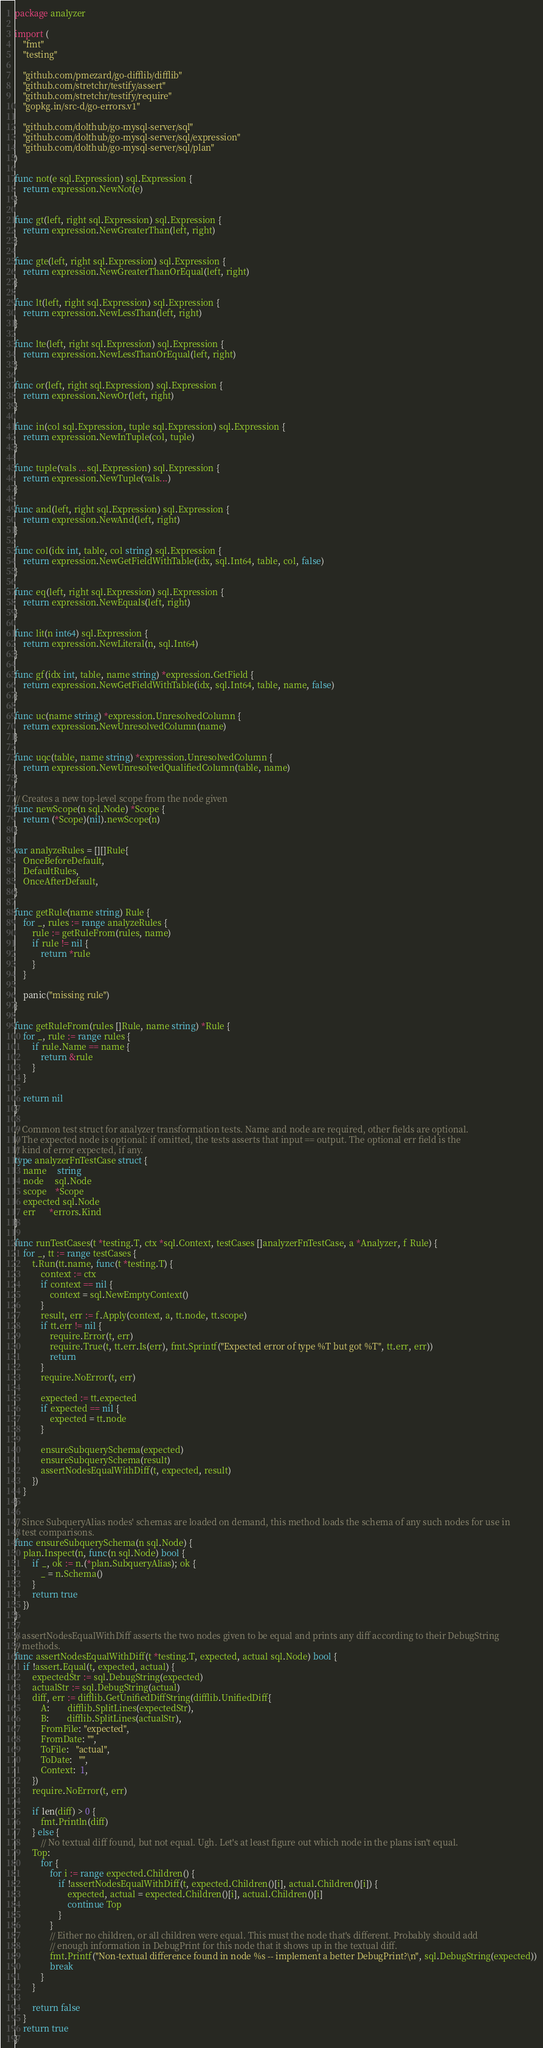<code> <loc_0><loc_0><loc_500><loc_500><_Go_>package analyzer

import (
	"fmt"
	"testing"

	"github.com/pmezard/go-difflib/difflib"
	"github.com/stretchr/testify/assert"
	"github.com/stretchr/testify/require"
	"gopkg.in/src-d/go-errors.v1"

	"github.com/dolthub/go-mysql-server/sql"
	"github.com/dolthub/go-mysql-server/sql/expression"
	"github.com/dolthub/go-mysql-server/sql/plan"
)

func not(e sql.Expression) sql.Expression {
	return expression.NewNot(e)
}

func gt(left, right sql.Expression) sql.Expression {
	return expression.NewGreaterThan(left, right)
}

func gte(left, right sql.Expression) sql.Expression {
	return expression.NewGreaterThanOrEqual(left, right)
}

func lt(left, right sql.Expression) sql.Expression {
	return expression.NewLessThan(left, right)
}

func lte(left, right sql.Expression) sql.Expression {
	return expression.NewLessThanOrEqual(left, right)
}

func or(left, right sql.Expression) sql.Expression {
	return expression.NewOr(left, right)
}

func in(col sql.Expression, tuple sql.Expression) sql.Expression {
	return expression.NewInTuple(col, tuple)
}

func tuple(vals ...sql.Expression) sql.Expression {
	return expression.NewTuple(vals...)
}

func and(left, right sql.Expression) sql.Expression {
	return expression.NewAnd(left, right)
}

func col(idx int, table, col string) sql.Expression {
	return expression.NewGetFieldWithTable(idx, sql.Int64, table, col, false)
}

func eq(left, right sql.Expression) sql.Expression {
	return expression.NewEquals(left, right)
}

func lit(n int64) sql.Expression {
	return expression.NewLiteral(n, sql.Int64)
}

func gf(idx int, table, name string) *expression.GetField {
	return expression.NewGetFieldWithTable(idx, sql.Int64, table, name, false)
}

func uc(name string) *expression.UnresolvedColumn {
	return expression.NewUnresolvedColumn(name)
}

func uqc(table, name string) *expression.UnresolvedColumn {
	return expression.NewUnresolvedQualifiedColumn(table, name)
}

// Creates a new top-level scope from the node given
func newScope(n sql.Node) *Scope {
	return (*Scope)(nil).newScope(n)
}

var analyzeRules = [][]Rule{
	OnceBeforeDefault,
	DefaultRules,
	OnceAfterDefault,
}

func getRule(name string) Rule {
	for _, rules := range analyzeRules {
		rule := getRuleFrom(rules, name)
		if rule != nil {
			return *rule
		}
	}

	panic("missing rule")
}

func getRuleFrom(rules []Rule, name string) *Rule {
	for _, rule := range rules {
		if rule.Name == name {
			return &rule
		}
	}

	return nil
}

// Common test struct for analyzer transformation tests. Name and node are required, other fields are optional.
// The expected node is optional: if omitted, the tests asserts that input == output. The optional err field is the
// kind of error expected, if any.
type analyzerFnTestCase struct {
	name     string
	node     sql.Node
	scope    *Scope
	expected sql.Node
	err      *errors.Kind
}

func runTestCases(t *testing.T, ctx *sql.Context, testCases []analyzerFnTestCase, a *Analyzer, f Rule) {
	for _, tt := range testCases {
		t.Run(tt.name, func(t *testing.T) {
			context := ctx
			if context == nil {
				context = sql.NewEmptyContext()
			}
			result, err := f.Apply(context, a, tt.node, tt.scope)
			if tt.err != nil {
				require.Error(t, err)
				require.True(t, tt.err.Is(err), fmt.Sprintf("Expected error of type %T but got %T", tt.err, err))
				return
			}
			require.NoError(t, err)

			expected := tt.expected
			if expected == nil {
				expected = tt.node
			}

			ensureSubquerySchema(expected)
			ensureSubquerySchema(result)
			assertNodesEqualWithDiff(t, expected, result)
		})
	}
}

// Since SubqueryAlias nodes' schemas are loaded on demand, this method loads the schema of any such nodes for use in
// test comparisons.
func ensureSubquerySchema(n sql.Node) {
	plan.Inspect(n, func(n sql.Node) bool {
		if _, ok := n.(*plan.SubqueryAlias); ok {
			_ = n.Schema()
		}
		return true
	})
}

// assertNodesEqualWithDiff asserts the two nodes given to be equal and prints any diff according to their DebugString
// methods.
func assertNodesEqualWithDiff(t *testing.T, expected, actual sql.Node) bool {
	if !assert.Equal(t, expected, actual) {
		expectedStr := sql.DebugString(expected)
		actualStr := sql.DebugString(actual)
		diff, err := difflib.GetUnifiedDiffString(difflib.UnifiedDiff{
			A:        difflib.SplitLines(expectedStr),
			B:        difflib.SplitLines(actualStr),
			FromFile: "expected",
			FromDate: "",
			ToFile:   "actual",
			ToDate:   "",
			Context:  1,
		})
		require.NoError(t, err)

		if len(diff) > 0 {
			fmt.Println(diff)
		} else {
			// No textual diff found, but not equal. Ugh. Let's at least figure out which node in the plans isn't equal.
		Top:
			for {
				for i := range expected.Children() {
					if !assertNodesEqualWithDiff(t, expected.Children()[i], actual.Children()[i]) {
						expected, actual = expected.Children()[i], actual.Children()[i]
						continue Top
					}
				}
				// Either no children, or all children were equal. This must the node that's different. Probably should add
				// enough information in DebugPrint for this node that it shows up in the textual diff.
				fmt.Printf("Non-textual difference found in node %s -- implement a better DebugPrint?\n", sql.DebugString(expected))
				break
			}
		}

		return false
	}
	return true
}
</code> 